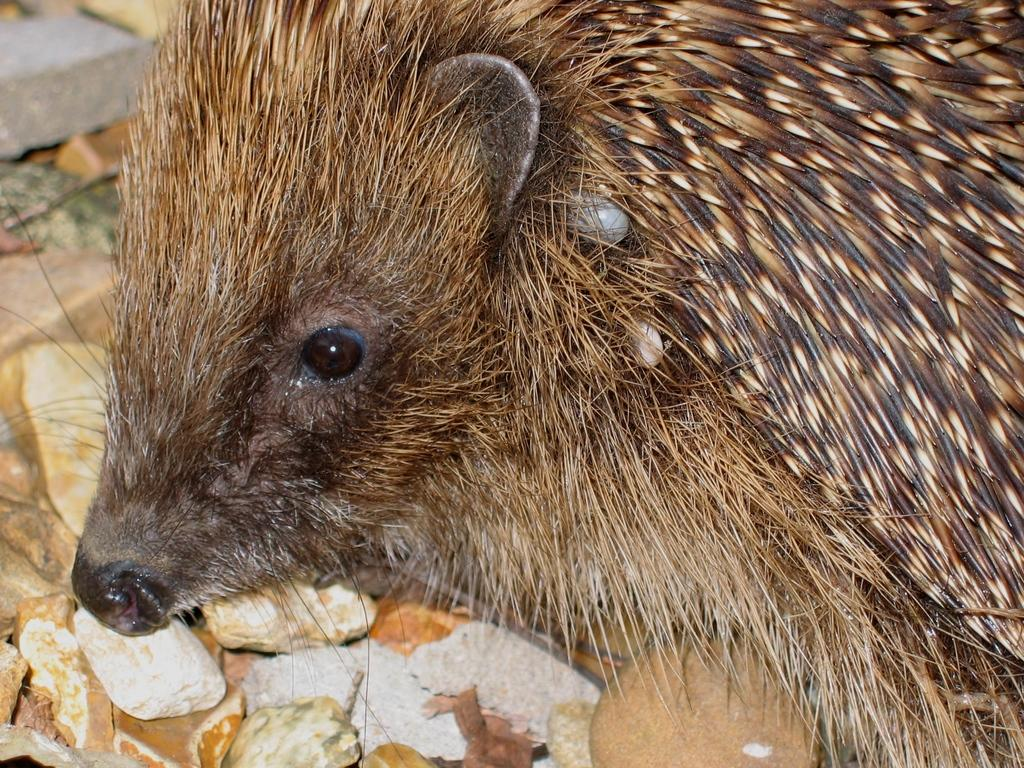What is located in the center of the image? There are stones in the center of the image. What animal can be seen on the stones? There is a rat on the stones. What is the color of the rat in the image? The rat is brown in color. Where is the hall located in the image? There is no hall present in the image. Can you describe the volleyball game happening in the image? There is no volleyball game present in the image. 